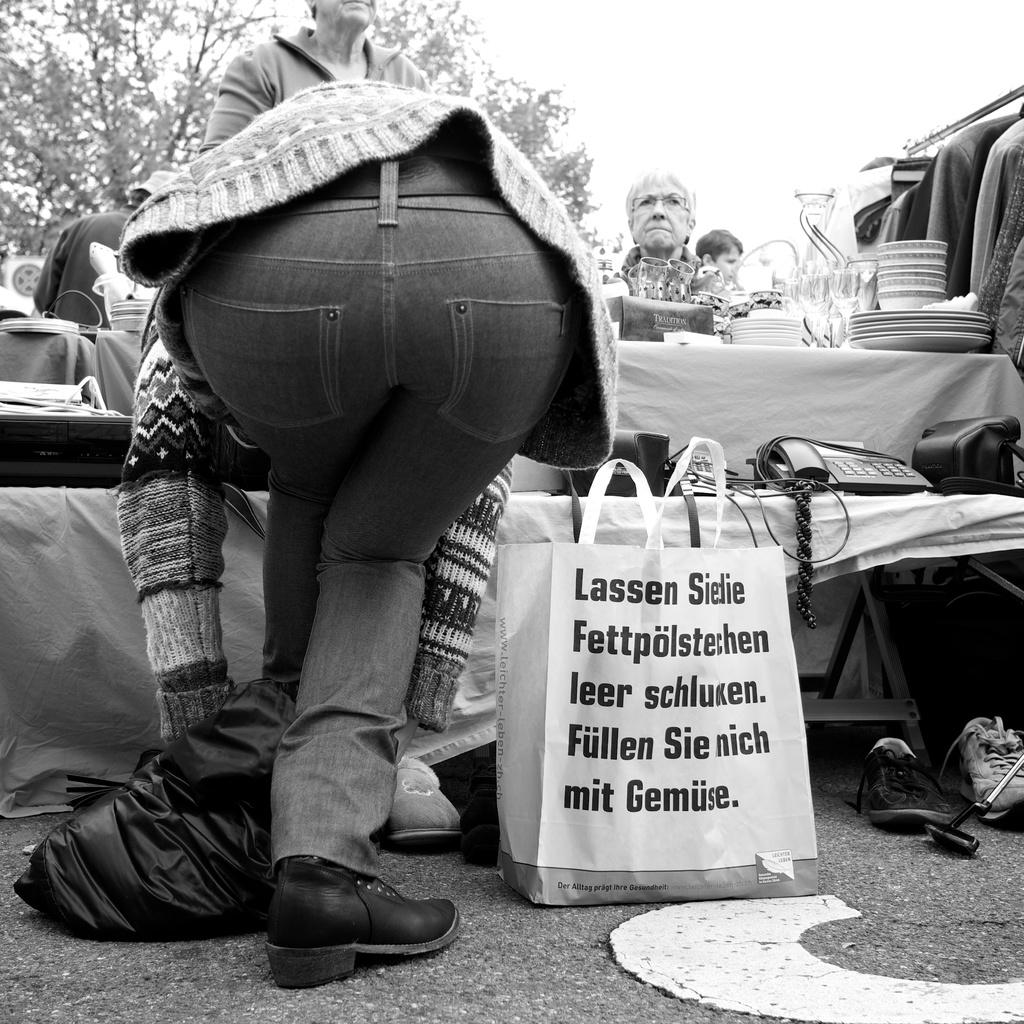What is the first word?
Give a very brief answer. Lassen. What is the last word on the bag?
Provide a succinct answer. Gemuse. 